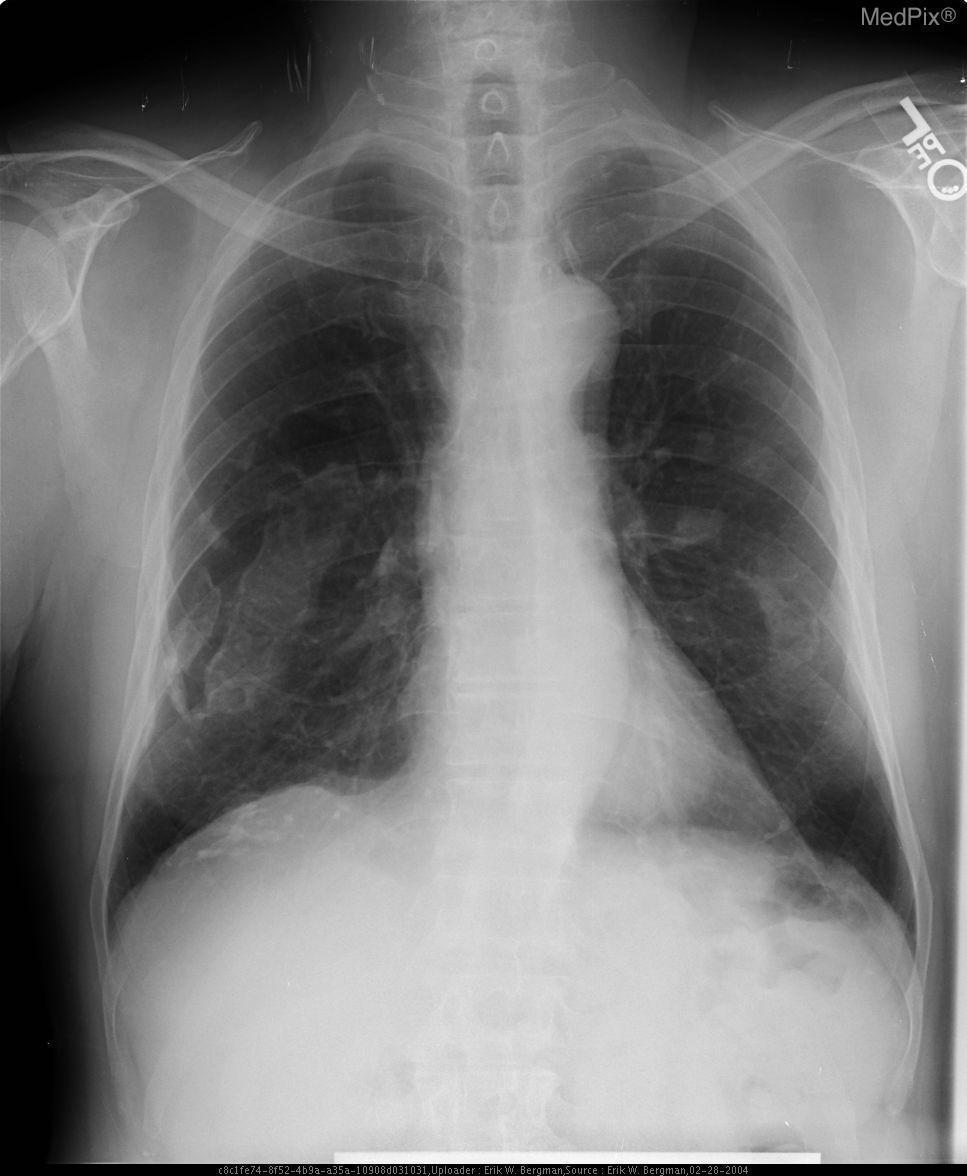Are the findings normal?
Concise answer only. No. Would you expect pleural plaques on other pleural surfaces vs just the hemithoraces?
Answer briefly. Not sure. Do you expect the patient to have plaques on other pleura as well?
Quick response, please. Maybe. What are the densities in both mid-lung fields?
Concise answer only. Pleural plaques. What do the densities in the lung fields represent?
Concise answer only. Pleural plaques. Are there any abnormalities with the shape of the aortic arch?
Short answer required. No. Is the aortic arch shape abnormal?
Keep it brief. No. 